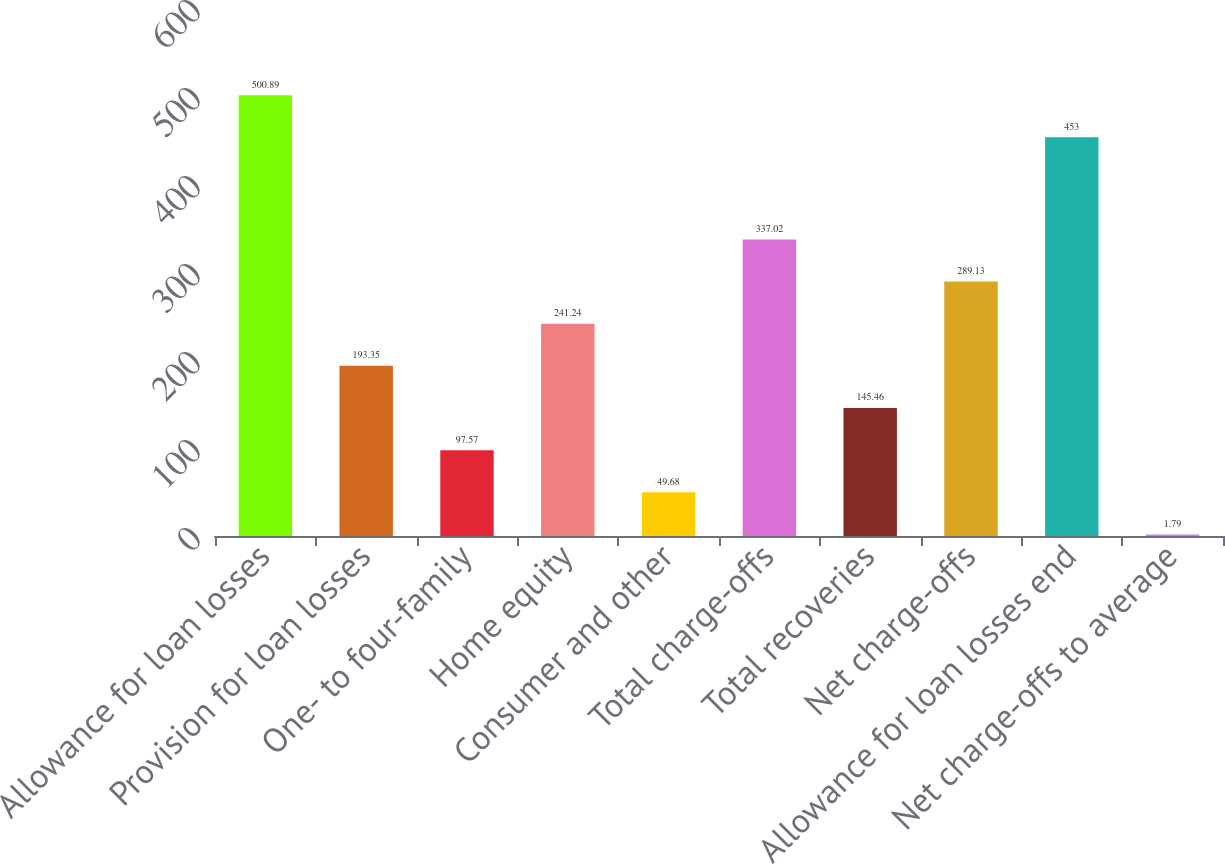Convert chart to OTSL. <chart><loc_0><loc_0><loc_500><loc_500><bar_chart><fcel>Allowance for loan losses<fcel>Provision for loan losses<fcel>One- to four-family<fcel>Home equity<fcel>Consumer and other<fcel>Total charge-offs<fcel>Total recoveries<fcel>Net charge-offs<fcel>Allowance for loan losses end<fcel>Net charge-offs to average<nl><fcel>500.89<fcel>193.35<fcel>97.57<fcel>241.24<fcel>49.68<fcel>337.02<fcel>145.46<fcel>289.13<fcel>453<fcel>1.79<nl></chart> 